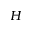<formula> <loc_0><loc_0><loc_500><loc_500>H</formula> 